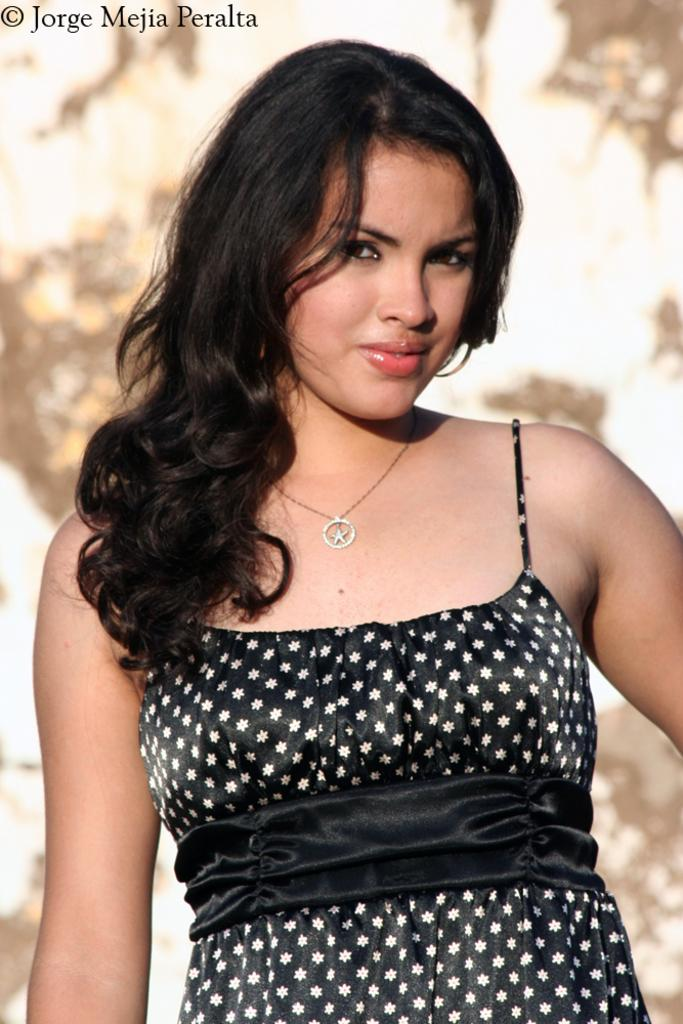Who is the main subject in the image? There is a woman in the image. Where is the woman located in relation to the image? The woman is standing in the foreground. What is the woman doing in the image? The woman is posing for a photo. How is the background of the image depicted? The background of the woman is blurred. What type of cellar can be seen in the background of the image? There is no cellar present in the image; the background is blurred. What type of border is visible between the woman and the background? There is no border visible between the woman and the background; the image is a continuous scene. 